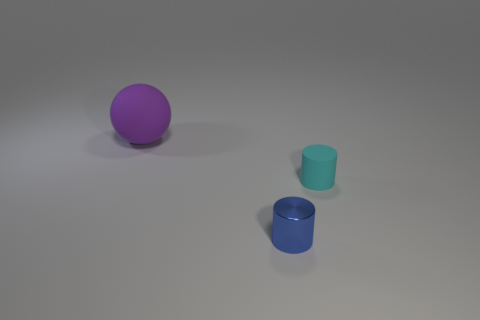How many things are either cylinders on the right side of the metal object or tiny blue shiny things? In the image, there is one blue cylinder on the right side of the purple sphere, which may be the metal object mentioned. However, since there's no scale provided, it's uncertain if the blue cylinder can be classified as 'tiny,' but it does appear shiny. Therefore, there is one object that definitely fits the description. 